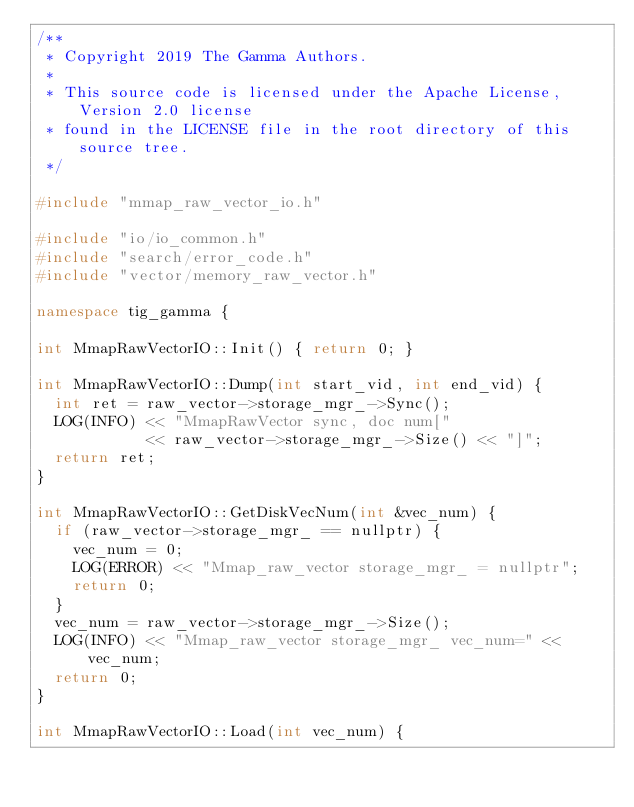Convert code to text. <code><loc_0><loc_0><loc_500><loc_500><_C++_>/**
 * Copyright 2019 The Gamma Authors.
 *
 * This source code is licensed under the Apache License, Version 2.0 license
 * found in the LICENSE file in the root directory of this source tree.
 */

#include "mmap_raw_vector_io.h"

#include "io/io_common.h"
#include "search/error_code.h"
#include "vector/memory_raw_vector.h"

namespace tig_gamma {

int MmapRawVectorIO::Init() { return 0; }

int MmapRawVectorIO::Dump(int start_vid, int end_vid) {
  int ret = raw_vector->storage_mgr_->Sync();
  LOG(INFO) << "MmapRawVector sync, doc num["
            << raw_vector->storage_mgr_->Size() << "]";
  return ret;
}

int MmapRawVectorIO::GetDiskVecNum(int &vec_num) {
  if (raw_vector->storage_mgr_ == nullptr) {
    vec_num = 0;
    LOG(ERROR) << "Mmap_raw_vector storage_mgr_ = nullptr";
    return 0;
  }
  vec_num = raw_vector->storage_mgr_->Size();
  LOG(INFO) << "Mmap_raw_vector storage_mgr_ vec_num=" << vec_num;
  return 0;
}

int MmapRawVectorIO::Load(int vec_num) {</code> 